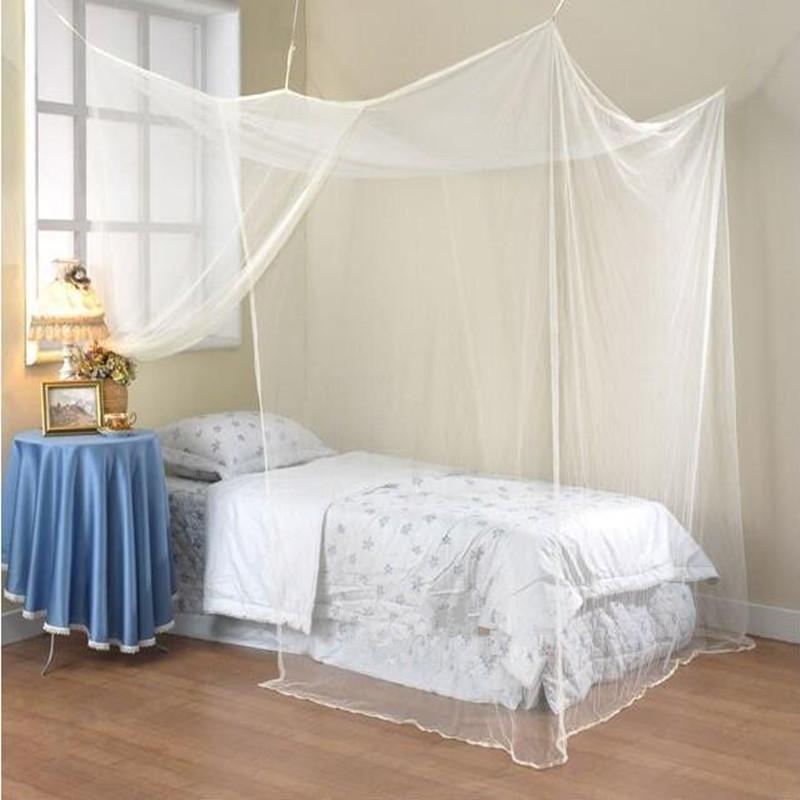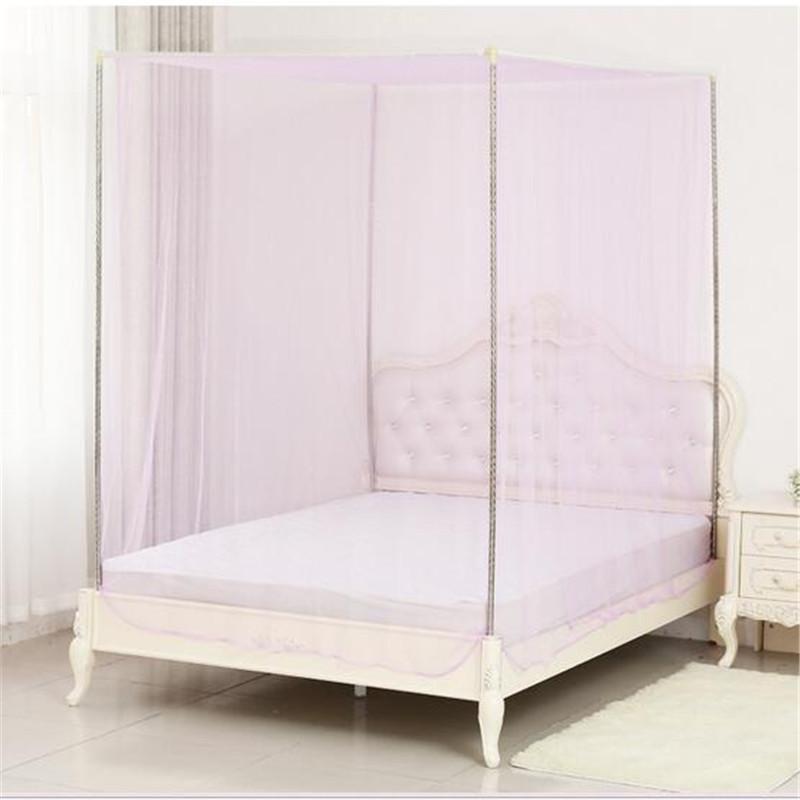The first image is the image on the left, the second image is the image on the right. Examine the images to the left and right. Is the description "A bed with its pillow on the left and a cloth-covered table alongside it has a canopy with each corner lifted by a strap." accurate? Answer yes or no. Yes. The first image is the image on the left, the second image is the image on the right. Analyze the images presented: Is the assertion "One mattress has no blanket, the other mattress has a light (mostly white) colored blanket." valid? Answer yes or no. Yes. 